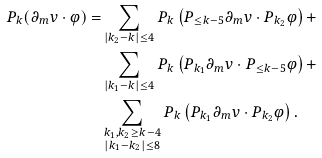Convert formula to latex. <formula><loc_0><loc_0><loc_500><loc_500>P _ { k } ( \partial _ { m } v \cdot \varphi ) = & \sum _ { | k _ { 2 } - k | \leq 4 } P _ { k } \left ( P _ { \leq k - 5 } \partial _ { m } v \cdot P _ { k _ { 2 } } \varphi \right ) + \\ & \sum _ { | k _ { 1 } - k | \leq 4 } P _ { k } \left ( P _ { k _ { 1 } } \partial _ { m } v \cdot P _ { \leq k - 5 } \varphi \right ) + \\ & \sum _ { \substack { k _ { 1 } , k _ { 2 } \geq k - 4 \\ | k _ { 1 } - k _ { 2 } | \leq 8 } } P _ { k } \left ( P _ { k _ { 1 } } \partial _ { m } v \cdot P _ { k _ { 2 } } \varphi \right ) .</formula> 